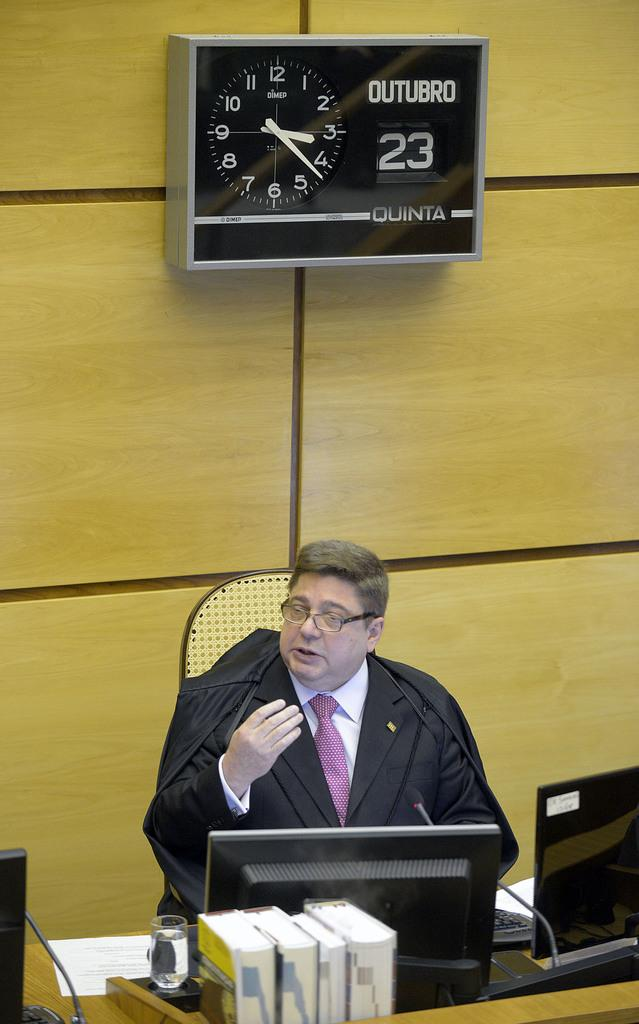Provide a one-sentence caption for the provided image. a clock on the wall behind a judge that reads: Outubro 23 Quinta. 